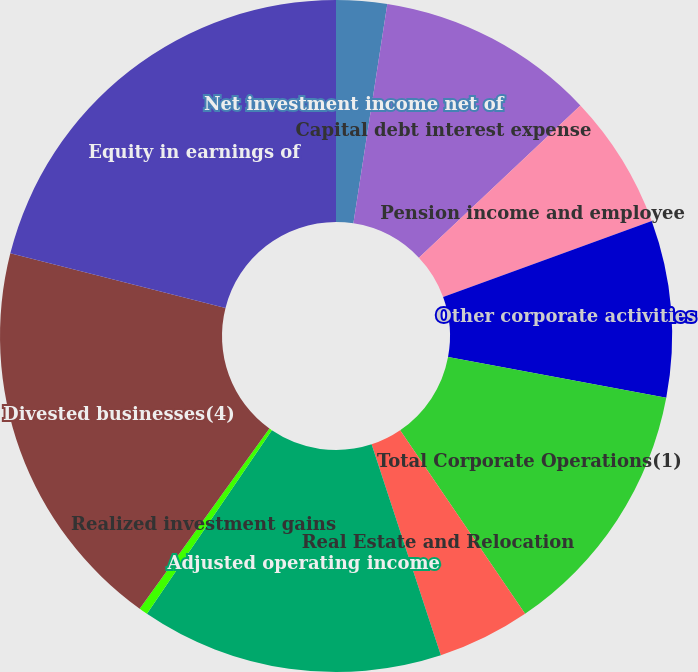Convert chart. <chart><loc_0><loc_0><loc_500><loc_500><pie_chart><fcel>Net investment income net of<fcel>Capital debt interest expense<fcel>Pension income and employee<fcel>Other corporate activities<fcel>Total Corporate Operations(1)<fcel>Real Estate and Relocation<fcel>Adjusted operating income<fcel>Realized investment gains<fcel>Divested businesses(4)<fcel>Equity in earnings of<nl><fcel>2.44%<fcel>10.52%<fcel>6.48%<fcel>8.5%<fcel>12.54%<fcel>4.46%<fcel>14.56%<fcel>0.42%<fcel>19.02%<fcel>21.04%<nl></chart> 